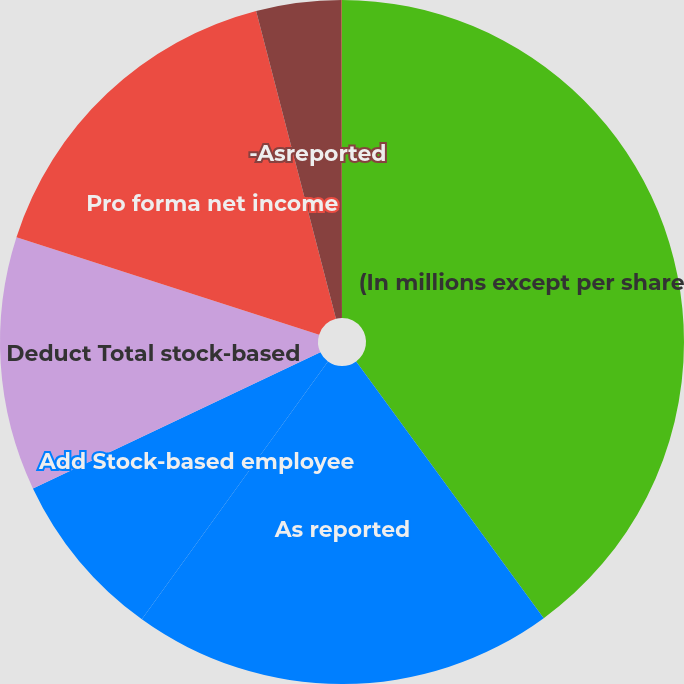Convert chart. <chart><loc_0><loc_0><loc_500><loc_500><pie_chart><fcel>(In millions except per share<fcel>As reported<fcel>Add Stock-based employee<fcel>Deduct Total stock-based<fcel>Pro forma net income<fcel>-Asreported<fcel>-Pro forma<nl><fcel>39.96%<fcel>19.99%<fcel>8.01%<fcel>12.0%<fcel>16.0%<fcel>4.02%<fcel>0.02%<nl></chart> 